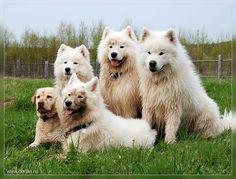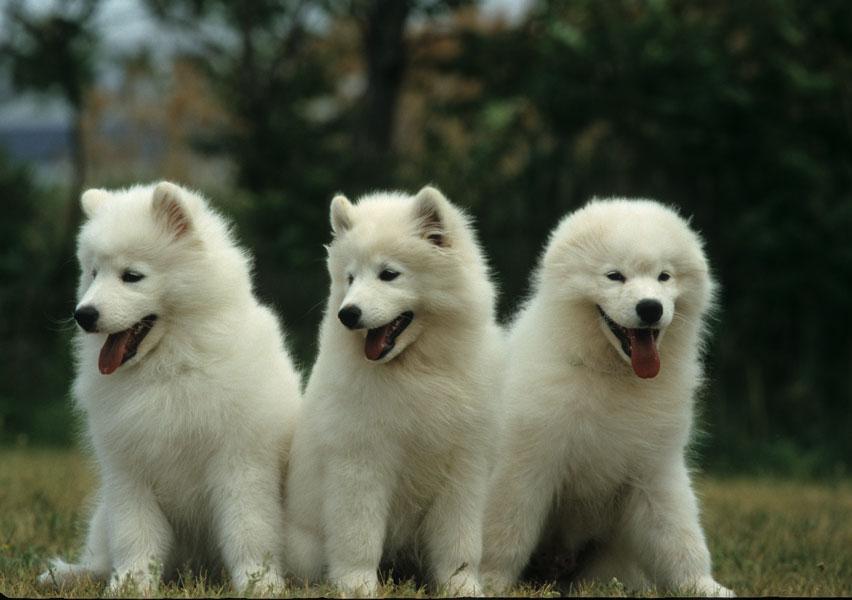The first image is the image on the left, the second image is the image on the right. Evaluate the accuracy of this statement regarding the images: "One of the images has exactly one dog.". Is it true? Answer yes or no. No. 